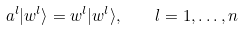<formula> <loc_0><loc_0><loc_500><loc_500>a ^ { l } | w ^ { l } \rangle = w ^ { l } | w ^ { l } \rangle , \quad l = 1 , \dots , n</formula> 